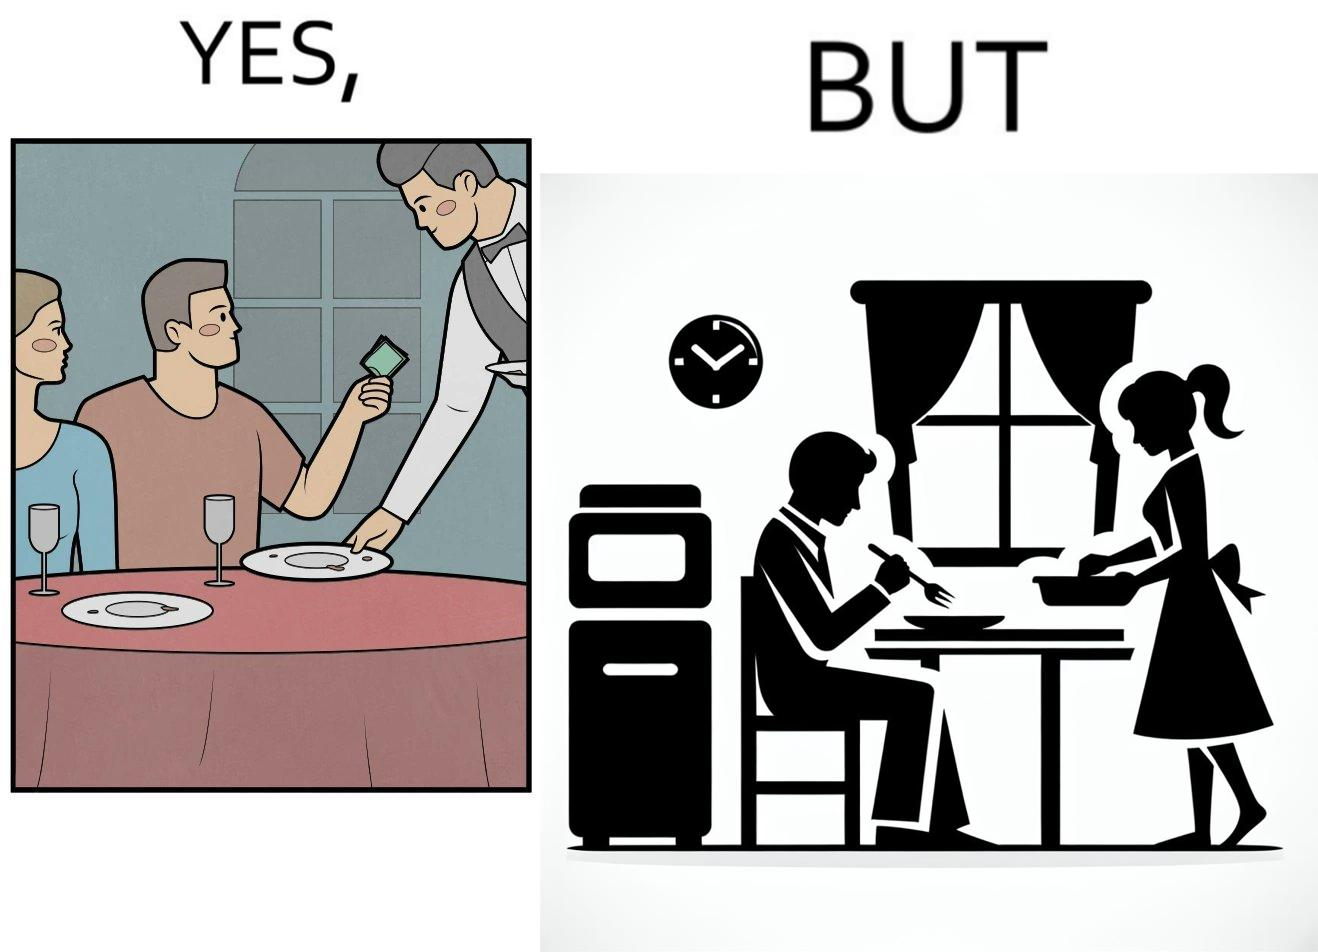What is shown in the left half versus the right half of this image? In the left part of the image: two people have finished their meal at a restaurant, while the waiter has come to pick up the plates, and the man is tipping the waiter. In the right part of the image: a man in his house has finished his meal while checking his phone, while a woman is picking up his plate. 